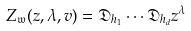Convert formula to latex. <formula><loc_0><loc_0><loc_500><loc_500>Z _ { \mathfrak { w } } ( z , \lambda , v ) = \mathfrak { D } _ { h _ { 1 } } \cdots \mathfrak { D } _ { h _ { d } } z ^ { \lambda }</formula> 